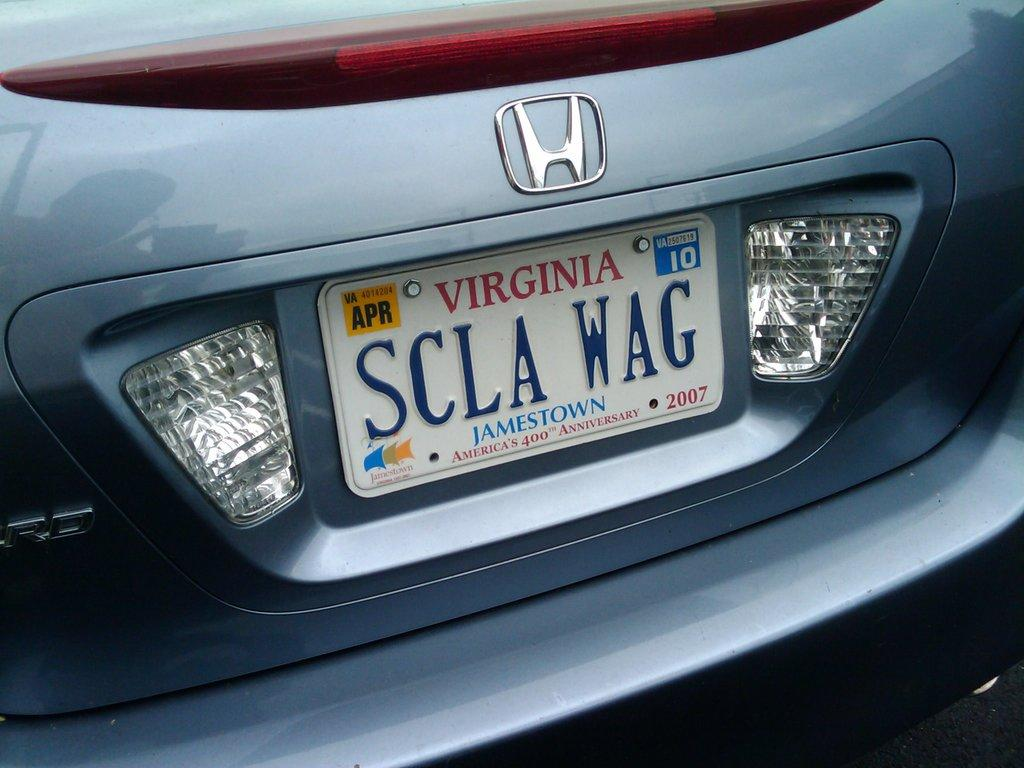<image>
Relay a brief, clear account of the picture shown. Silver honda vehicle with the state of Virginia license plates. 